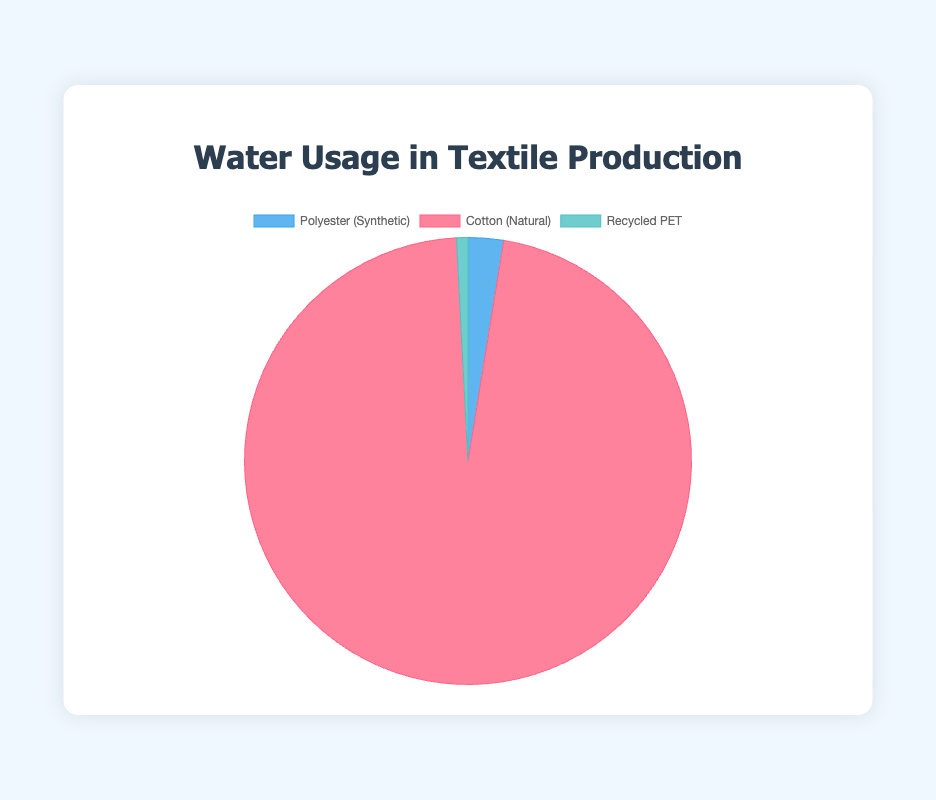What type of fiber has the highest water usage per kilogram? The figure shows water usage for different types of fibers. Cotton, labeled as natural fiber, uses 10,000 liters per kilogram, which is higher than both synthetic and recycled fibers.
Answer: Cotton Which fiber type uses the least water per kilogram? Evaluating the three fiber types, Polyester (Synthetic) uses 265 L/kg, Cotton (Natural) uses 10,000 L/kg, and Recycled PET uses 85 L/kg. Recycled PET has the lowest water usage.
Answer: Recycled PET What is the difference in water usage between the fiber with the highest and lowest water usage? The highest water use is by Cotton at 10,000 L/kg and the lowest is by Recycled PET at 85 L/kg. The difference is 10,000 - 85 = 9,915 L/kg.
Answer: 9,915 L/kg How much more water does Cotton use compared to Polyester? Water usage for Cotton is 10,000 L/kg and for Polyester is 265 L/kg. The difference is 10,000 - 265 = 9,735 L/kg.
Answer: 9,735 L/kg What is the percentage of water usage by Polyester compared to the total water usage by all three fiber types? The total water usage is 10,000 (Cotton) + 265 (Polyester) + 85 (Recycled PET) = 10,350 L/kg. The percentage for Polyester is (265 / 10,350) * 100% = 2.56%.
Answer: 2.56% Which fiber types are represented by red and blue colors in the pie chart? Cotton is represented by the red color and Polyester by the blue color in the pie chart, as indicated by the visuals.
Answer: Cotton and Polyester What is the total water usage for all three fiber types combined? Summing the water usage: Cotton (10,000 L/kg) + Polyester (265 L/kg) + Recycled PET (85 L/kg) = 10,350 L/kg.
Answer: 10,350 L/kg By how many liters does Recycled PET exceed Polyester in terms of lower water usage? Polyester uses 265 L/kg while Recycled PET uses 85 L/kg. The difference in water usage is 265 - 85 = 180 L/kg, meaning Recycled PET uses 180 liters less.
Answer: 180 L/kg What is the average water usage per kilogram across all three fiber types? The total water usage for the three fiber types is 10,350 L/kg. The average is calculated by dividing by the number of types: 10,350 / 3 = 3,450 L/kg.
Answer: 3,450 L/kg 